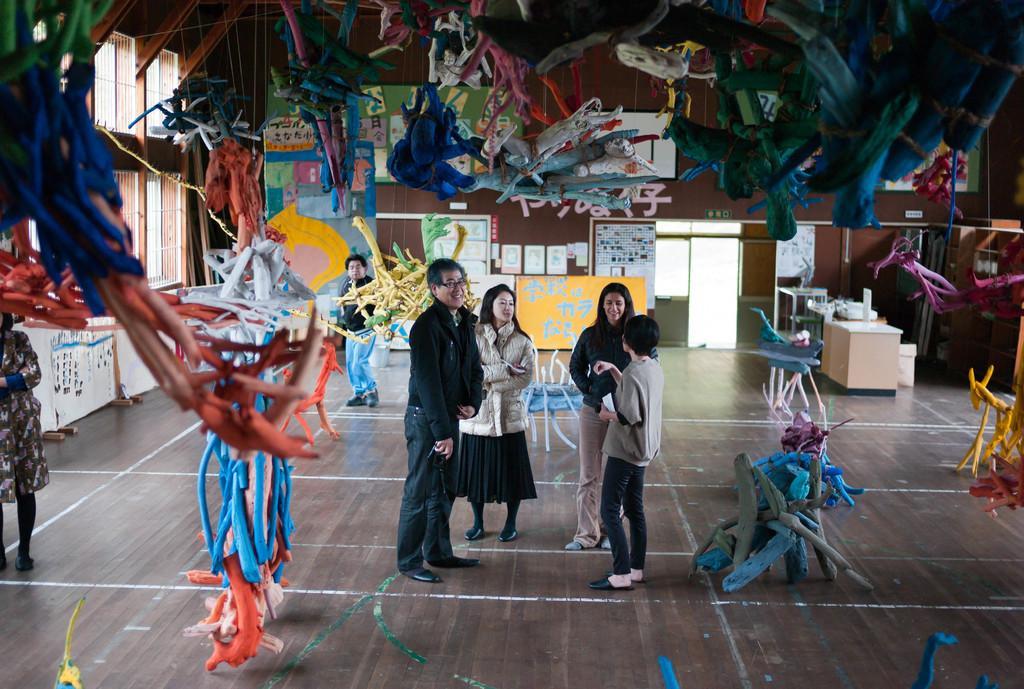Can you describe this image briefly? In the image I can see some people on the floor and around there are some things which are hanged and placed on the floor and also I can see some posters, tables, chairs and some other things around. 